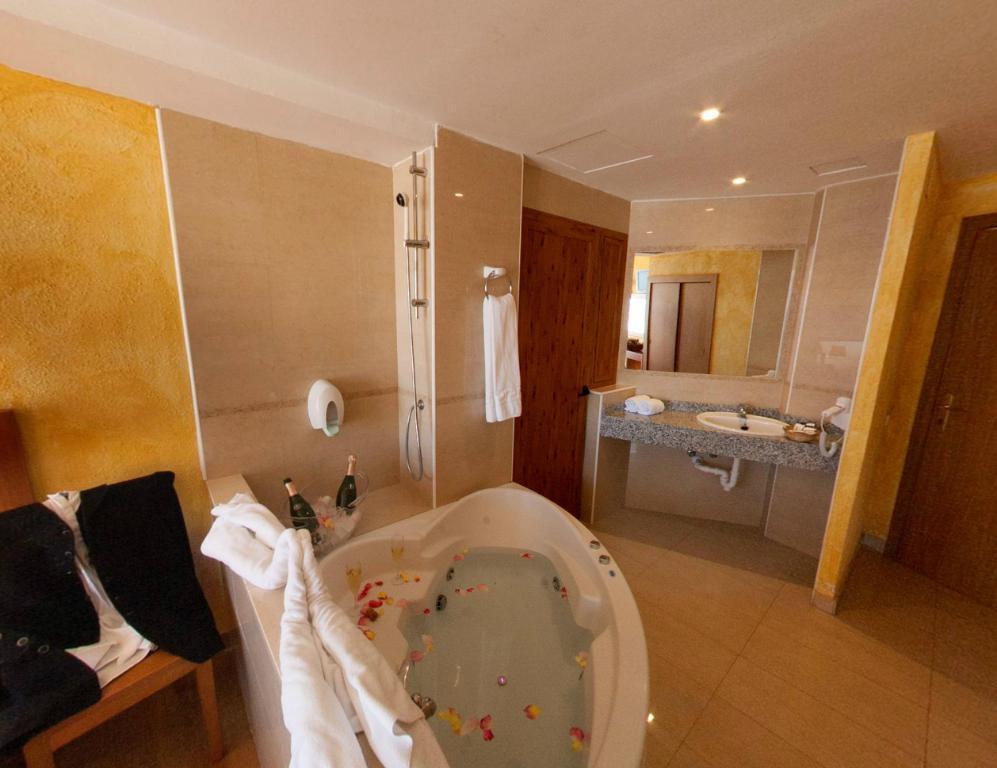Could you give a brief overview of what you see in this image? In this image I can see a bathtub which is white in color with some water and few objects in it. I can see few clothes, few bottles, the floor, the wall, the mirror, the sink , two doors, the ceiling and few lights to the ceiling. 